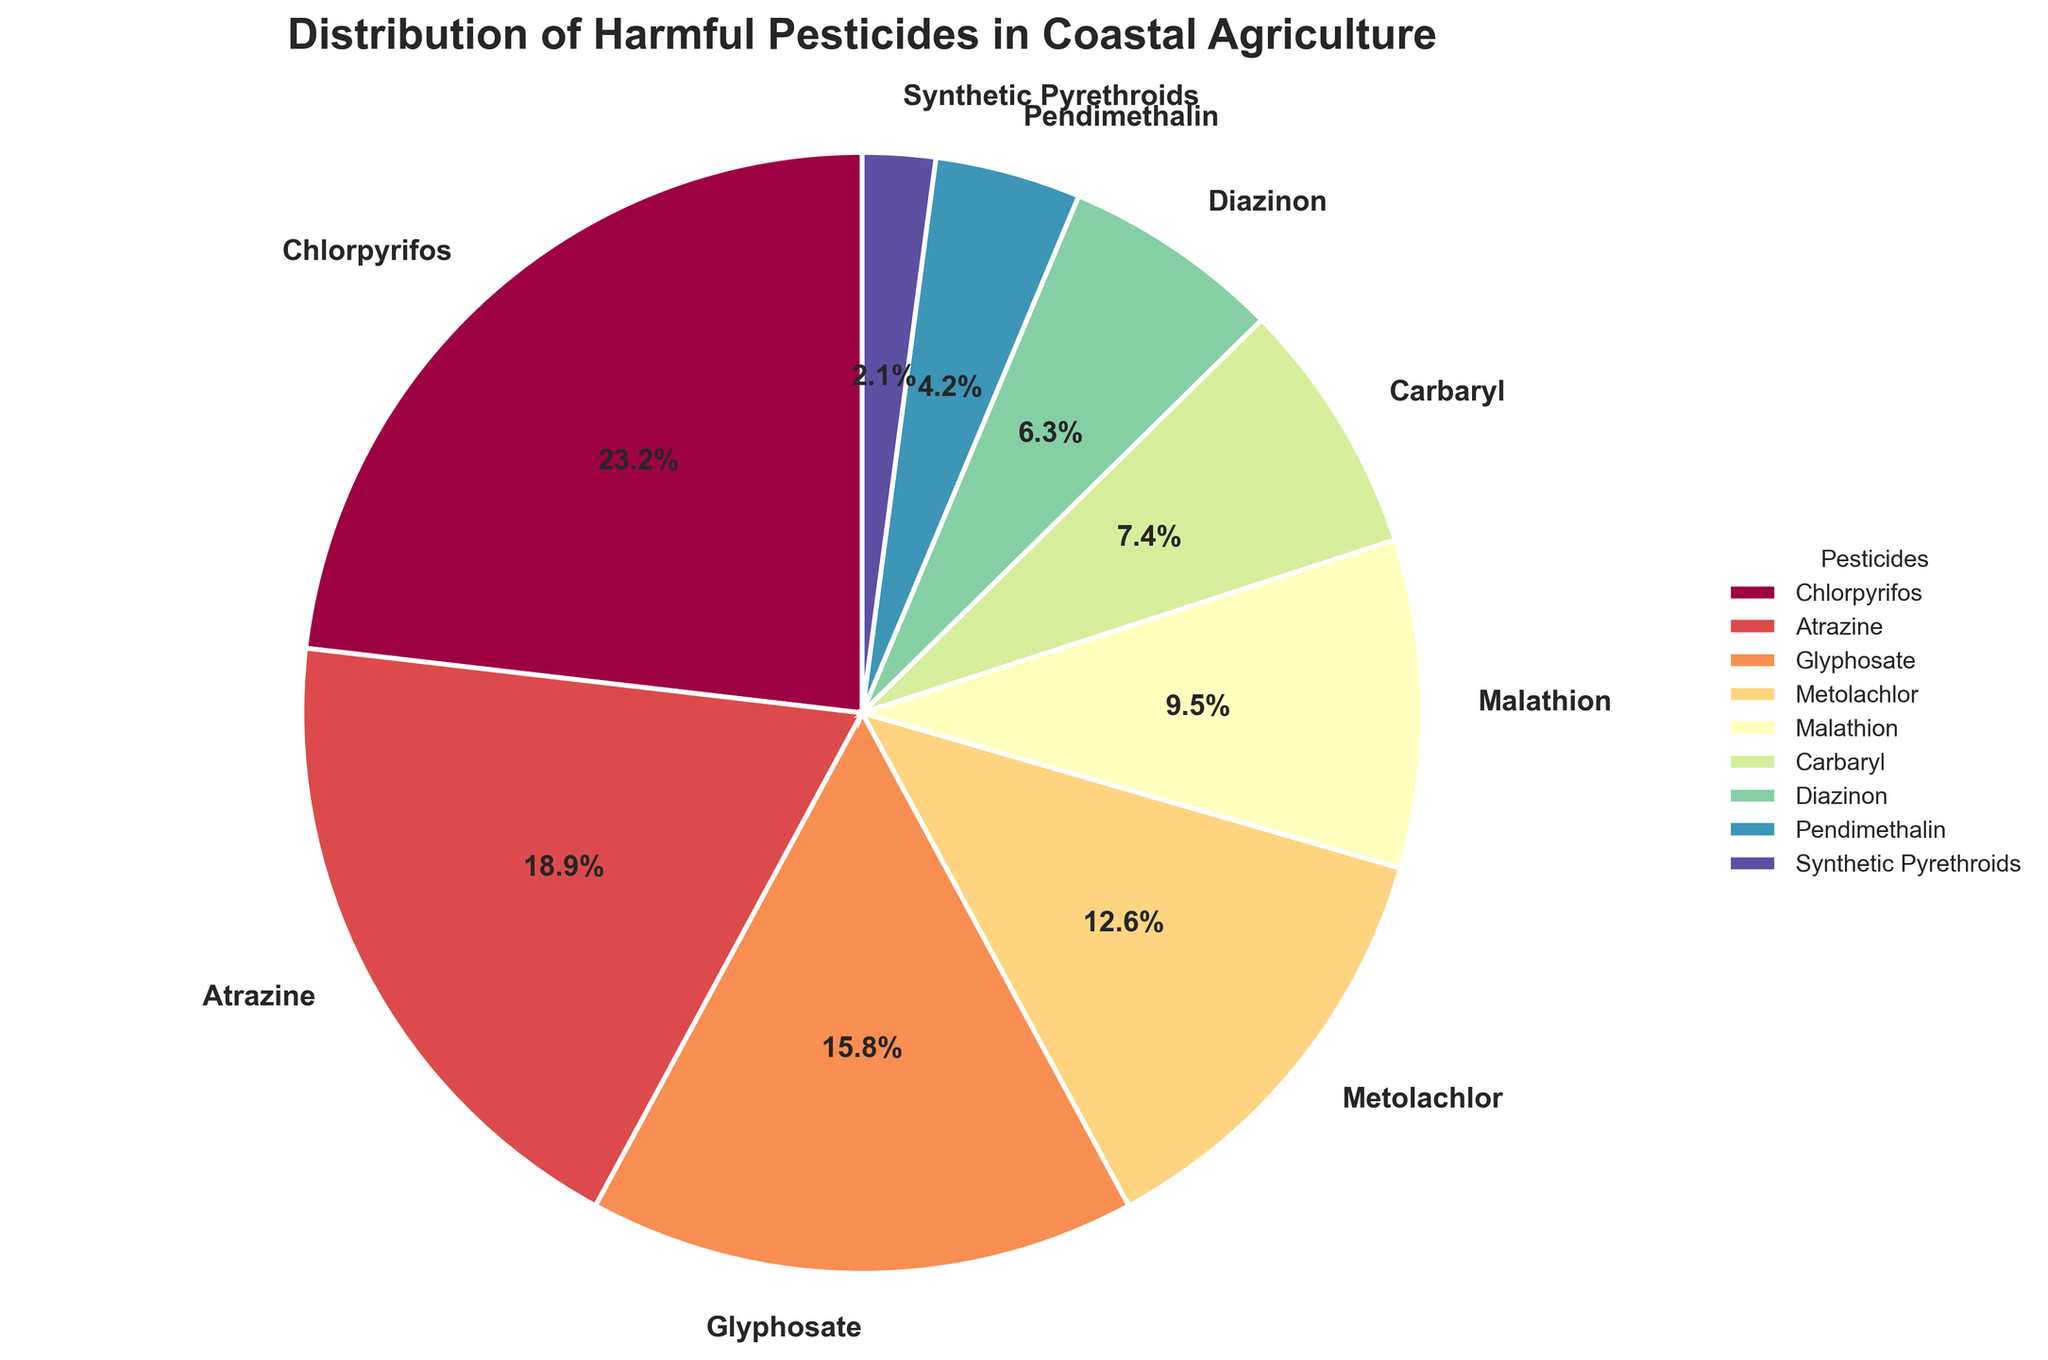What is the percentage of Chlorpyrifos used in coastal agriculture? Chlorpyrifos is labeled on the pie chart with its corresponding percentage. By examining the figure, we see Chlorpyrifos represents 22%.
Answer: 22% Which pesticide is used the least in coastal agriculture? The segment representing Synthetic Pyrethroids is the smallest and its label shows it has the lowest percentage at 2%.
Answer: Synthetic Pyrethroids How much more percentage of Chlorpyrifos is used compared to Glyphosate? Chlorpyrifos is 22% and Glyphosate is 15%. 22% - 15% = 7% more.
Answer: 7% Which two pesticides combined make up 30% of the usage? By examining their labels, we see that Carbaryl is 7% and Diazinon is 6%. Together, these do not add up to 30%. Trying other combinations, Metolachlor at 12% and Malathion at 9% still doesn’t match. Atrazine (18%) and Glyphosate (15%) sum up to 33%, which is still above. Finally, Glyphosate (15%) and Malathion (9%) + Pendimethalin (4%) sum to 28%, close but not exact. The direct combination of Atrazine and Metolachlor forms 18% + 12% = 30%.
Answer: Atrazine and Metolachlor Rank the top three pesticides in terms of their usage percentages. By inspecting the pie chart sectors, the top three are Chlorpyrifos (22%), Atrazine (18%), and Glyphosate (15%) in decreasing order.
Answer: Chlorpyrifos, Atrazine, Glyphosate What percentage of pesticides used is by others than the top three most used? The top three pesticides are Chlorpyrifos (22%), Atrazine (18%), and Glyphosate (15%), summing to 22% + 18% + 15% = 55%. The total of all pesticides is 100%, so the remaining is 100% - 55% = 45%.
Answer: 45% Compare and contrast the usage percentages of Malathion and Diazinon. Malathion represents 9% of the usage, while Diazinon accounts for 6%. Malathion is used 3% more than Diazinon.
Answer: Malathion is used 3% more What is the combined percentage of the least three used pesticides? The least three used pesticides are Synthetic Pyrethroids (2%), Pendimethalin (4%), and Diazinon (6%). Their combined percentage is 2% + 4% + 6% = 12%.
Answer: 12% Which pesticide has slightly lesser usage than Malathion in the chart? Malathion has 9% usage. By examining the chart, Carbaryl has slightly lesser usage at 7%.
Answer: Carbaryl What is the average percentage of the four least used pesticides? The four least used pesticides are Pendimethalin (4%), Diazinon (6%), Carbaryl (7%), and Synthetic Pyrethroids (2%). Their average is (4% + 6% + 7% + 2%) / 4 = 19% / 4 = 4.75%.
Answer: 4.75% 